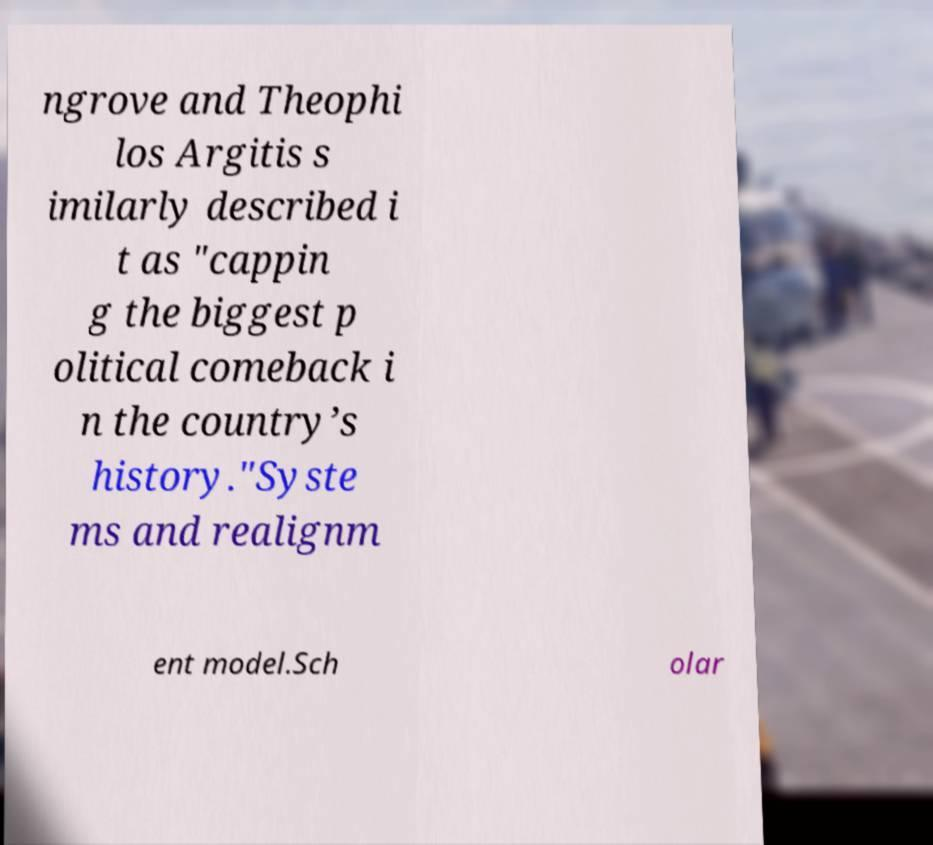I need the written content from this picture converted into text. Can you do that? ngrove and Theophi los Argitis s imilarly described i t as "cappin g the biggest p olitical comeback i n the country’s history."Syste ms and realignm ent model.Sch olar 